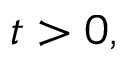Convert formula to latex. <formula><loc_0><loc_0><loc_500><loc_500>t > 0 ,</formula> 